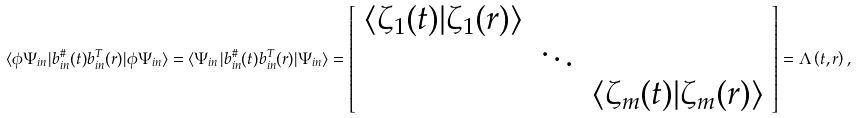<formula> <loc_0><loc_0><loc_500><loc_500>\langle \phi \Psi _ { i n } | b _ { i n } ^ { \# } ( t ) b _ { i n } ^ { T } ( r ) | \phi \Psi _ { i n } \rangle = \langle \Psi _ { i n } | b _ { i n } ^ { \# } ( t ) b _ { i n } ^ { T } ( r ) | \Psi _ { i n } \rangle = \left [ \begin{array} { c c c } \langle \zeta _ { 1 } ( t ) | \zeta _ { 1 } ( r ) \rangle & & \\ & \ddots & \\ & & \langle \zeta _ { m } ( t ) | \zeta _ { m } ( r ) \rangle \end{array} \right ] = \Lambda \left ( t , r \right ) ,</formula> 